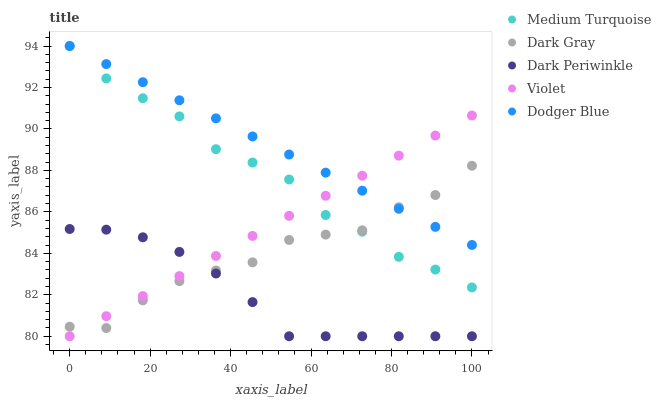Does Dark Periwinkle have the minimum area under the curve?
Answer yes or no. Yes. Does Dodger Blue have the maximum area under the curve?
Answer yes or no. Yes. Does Dodger Blue have the minimum area under the curve?
Answer yes or no. No. Does Dark Periwinkle have the maximum area under the curve?
Answer yes or no. No. Is Violet the smoothest?
Answer yes or no. Yes. Is Dark Gray the roughest?
Answer yes or no. Yes. Is Dodger Blue the smoothest?
Answer yes or no. No. Is Dodger Blue the roughest?
Answer yes or no. No. Does Dark Periwinkle have the lowest value?
Answer yes or no. Yes. Does Dodger Blue have the lowest value?
Answer yes or no. No. Does Medium Turquoise have the highest value?
Answer yes or no. Yes. Does Dark Periwinkle have the highest value?
Answer yes or no. No. Is Dark Periwinkle less than Dodger Blue?
Answer yes or no. Yes. Is Dodger Blue greater than Dark Periwinkle?
Answer yes or no. Yes. Does Violet intersect Dark Gray?
Answer yes or no. Yes. Is Violet less than Dark Gray?
Answer yes or no. No. Is Violet greater than Dark Gray?
Answer yes or no. No. Does Dark Periwinkle intersect Dodger Blue?
Answer yes or no. No. 